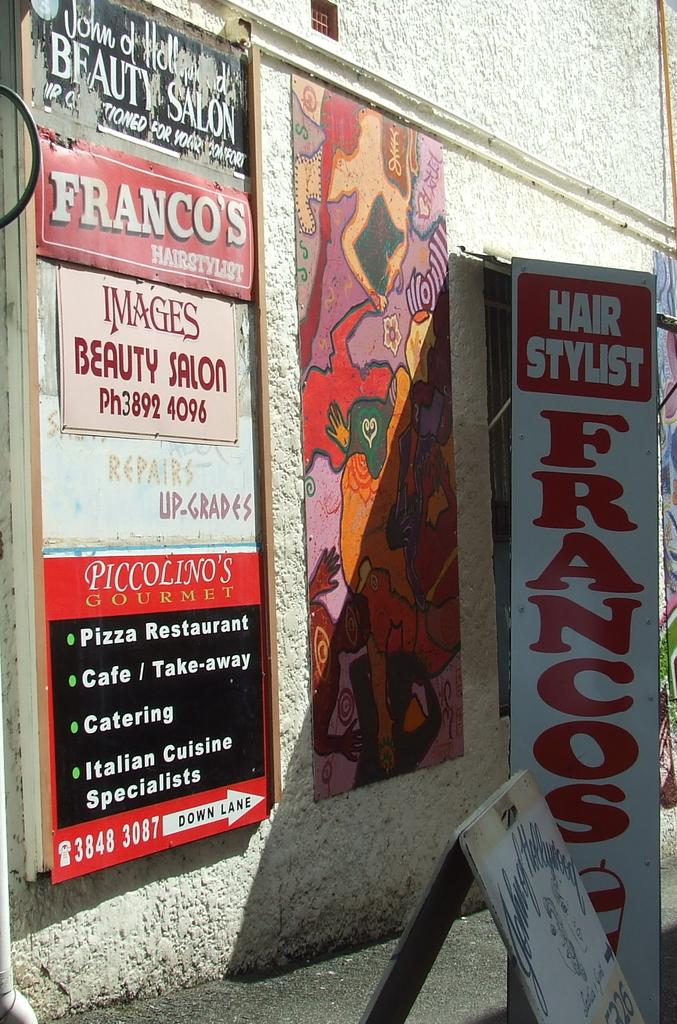<image>
Share a concise interpretation of the image provided. The side of a building that is advertising Franco's beauty Salon 